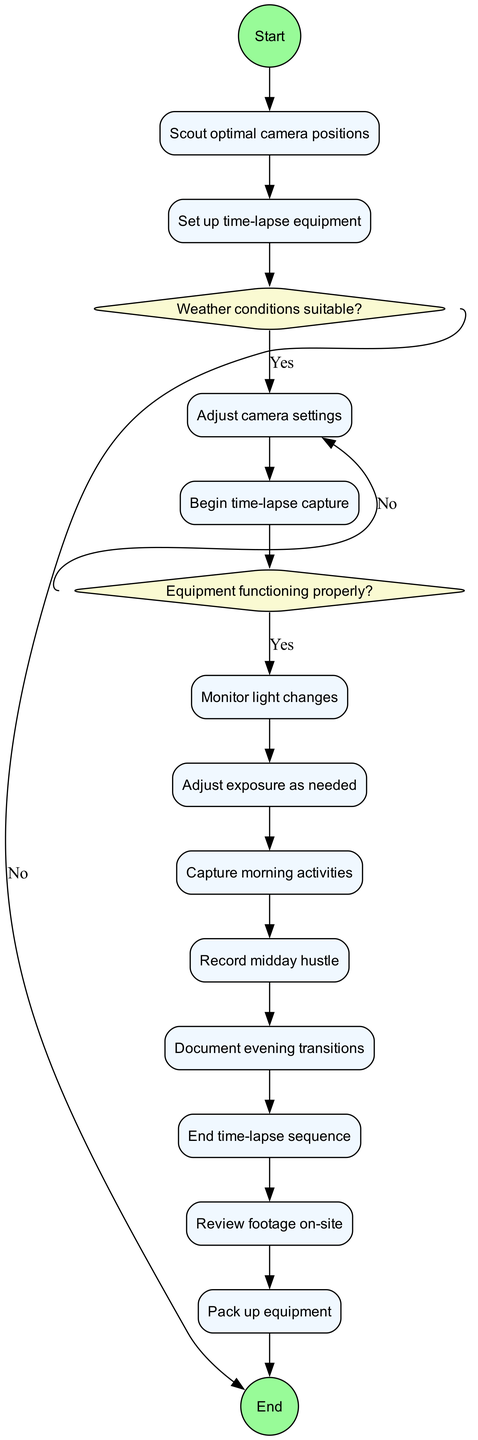What is the initial activity after arriving at Kathmandu Durbar Square? The diagram shows that the first activity after the initial node is "Scout optimal camera positions," indicating that this is the first step taken once the filmmaker arrives.
Answer: Scout optimal camera positions What happens if the weather conditions are unsuitable? According to the decision node labeled "Weather conditions suitable?", if the answer is "No", the flow continues to "Reschedule for better day", indicating that the filmmaker would delay the project for a more favorable day.
Answer: Reschedule for better day How many activities are listed in the diagram? By counting the activities specified in the diagram, there are a total of 12 activities including setups and different capturing times throughout the day.
Answer: 12 What is the last activity before reviewing footage on-site? The last activity prior to "Review footage on-site" is "End time-lapse sequence," as per the sequence leading to the review process.
Answer: End time-lapse sequence What are the two outcomes of the decision on whether the equipment is functioning properly? The decision node "Equipment functioning properly?" leads to two outcomes: If yes, it continues to "Proceed with capture," and if no, it leads to "Troubleshoot and fix issues."
Answer: Proceed with capture, Troubleshoot and fix issues What activity follows the adjustment of exposure? After "Adjust exposure as needed," the next activity is "Capture morning activities," which is specified in the sequence of activities.
Answer: Capture morning activities How many decision nodes are present in the diagram? The diagram includes two decision nodes, one related to weather conditions and the other concerning equipment functionality, making a total of two.
Answer: 2 What activity occurs immediately after "Document evening transitions"? According to the flow of activities, the task that follows "Document evening transitions" is "End time-lapse sequence."
Answer: End time-lapse sequence 